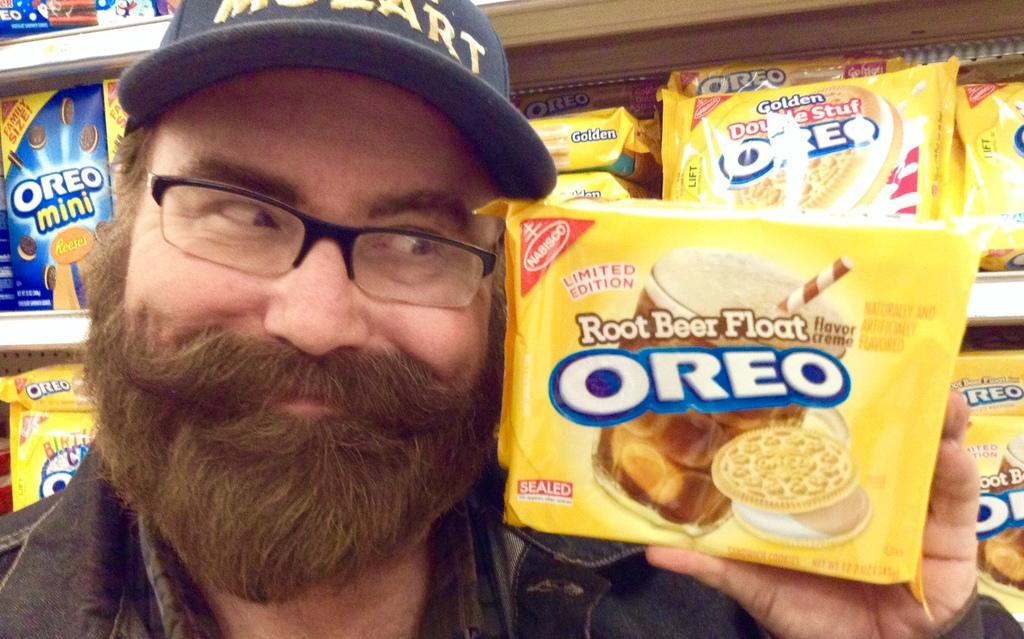What is the main subject of the image? There is a person in the image. Can you describe the person's attire? The person is wearing a black dress, specs, and a cap. What is the person holding in the image? The person is holding an Oreo packet. What can be seen in the background of the image? There is a rack with many food items in the background of the image. What type of meat is being cooked on the flame in the image? There is no meat or flame present in the image; it features a person holding an Oreo packet and a background with food items on a rack. Can you tell me how many cameras are visible in the image? There are no cameras visible in the image. 